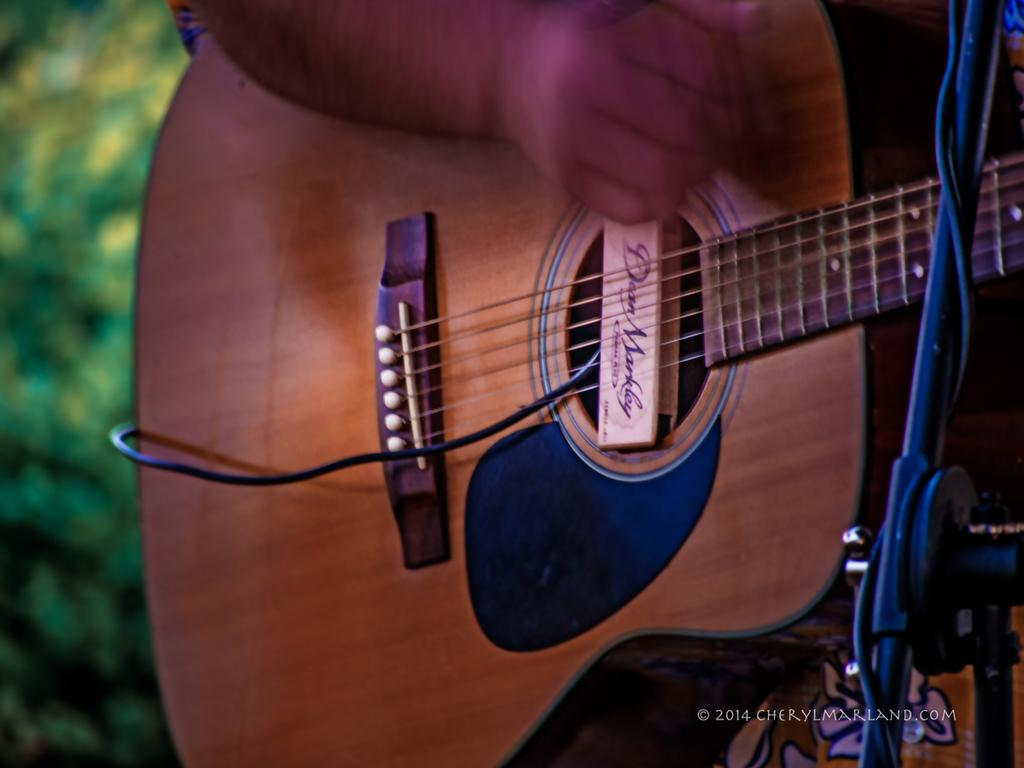What is the person in the image doing? The person is playing a guitar. Can you describe the background of the image? There is a tree in the background of the image. How many frogs are sitting on the person's head in the image? There are no frogs present in the image. What type of home is visible in the background of the image? There is no home visible in the image; only a tree is present in the background. 